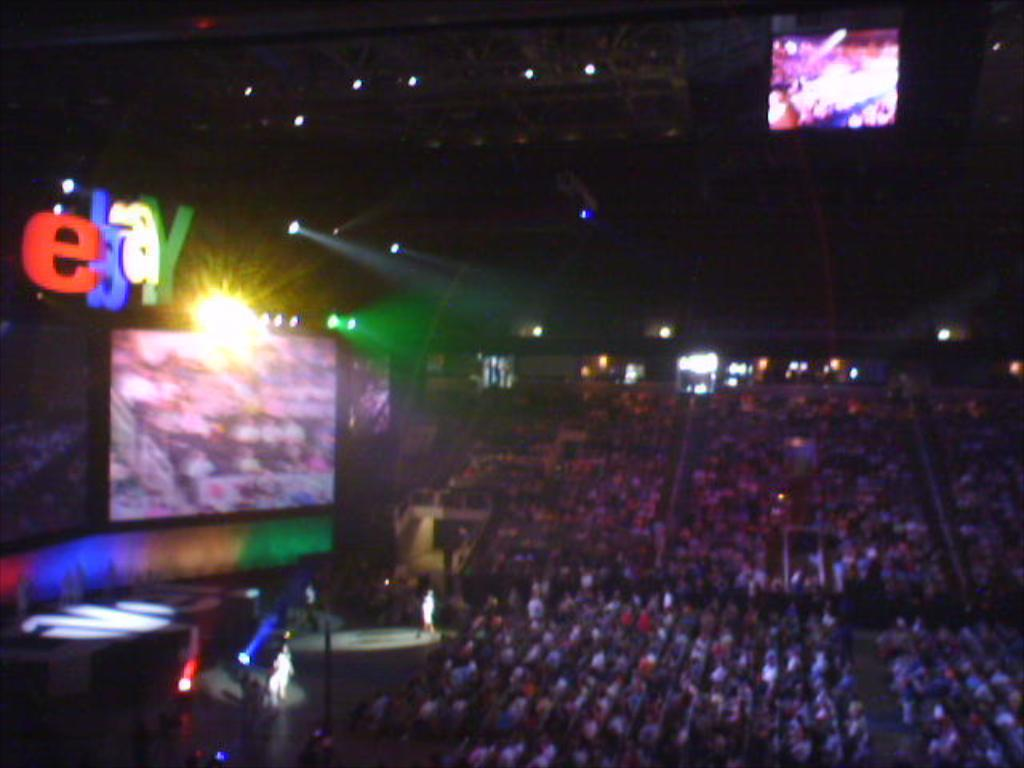<image>
Give a short and clear explanation of the subsequent image. an eBay logo that is above the people in a concert arena 